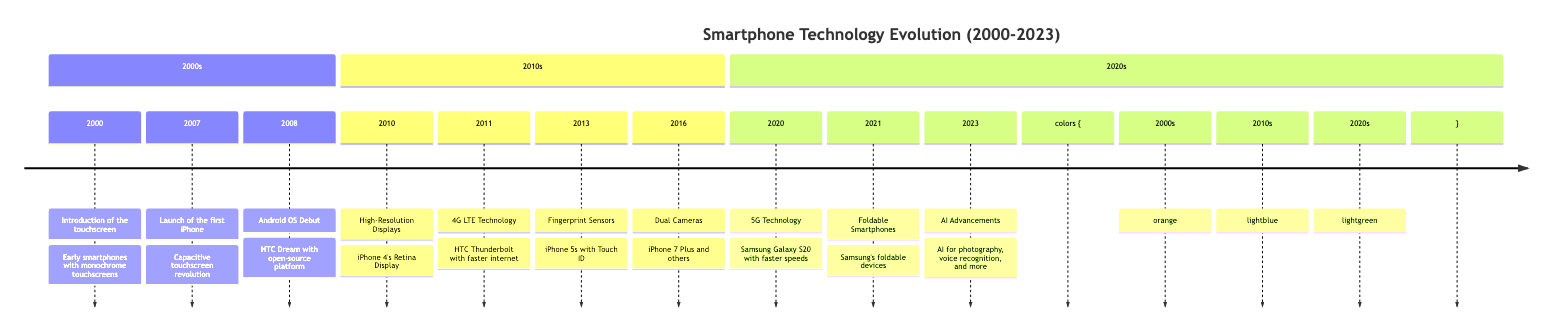What year was the first iPhone launched? According to the timeline, the launch of the first iPhone occurred in 2007.
Answer: 2007 What technology was introduced in 2000? The event in 2000 describes the introduction of the touchscreen in early smartphones.
Answer: Touchscreen Which smartphone first featured a fingerprint sensor? The timeline states that the iPhone 5s introduced Touch ID, which is a fingerprint sensor.
Answer: iPhone 5s How many major advances were made in smartphone technology between 2000 and 2023? Counting the events listed on the timeline, there are a total of 10 major advances from 2000 to 2023.
Answer: 10 What was a key feature of the iPhone 4 introduced in 2010? The timeline details that the iPhone 4 introduced the Retina Display, which is a high-resolution screen.
Answer: Retina Display Which year marked the introduction of 5G technology? The timeline indicates that 5G technology was introduced in the year 2020, starting with devices like the Samsung Galaxy S20.
Answer: 2020 What significant advancement in smartphone design occurred in 2021? The timeline shows that in 2021, foldable smartphones were released, which represented a new design capability.
Answer: Foldable Smartphones Between 2011 and 2013, which smartphone feature improved security? The introduction of fingerprint sensors in the iPhone 5s in 2013 improved smartphone security over previous models.
Answer: Fingerprint Sensors How many events are listed in the section for the 2010s? The section for the 2010s contains four significant events according to the timeline.
Answer: 4 